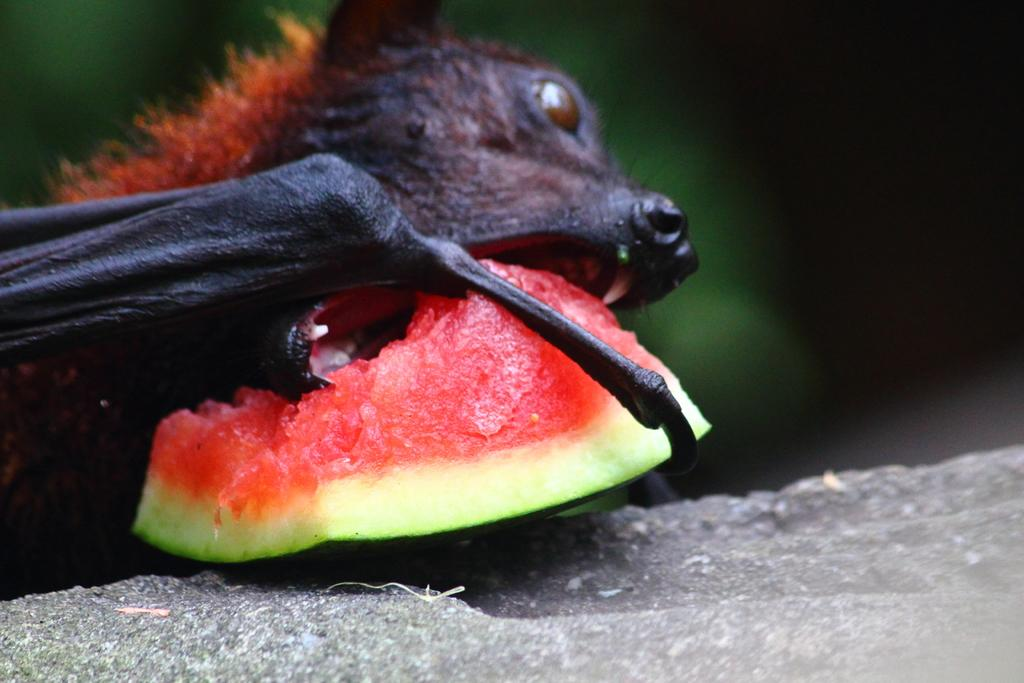What type of animal can be seen in the image? There is a black color animal in the image. What fruit is present in the image? There is a watermelon in the image. Can you describe the background of the image? The background of the image is blurred. What type of shade is covering the animal in the image? There is no shade covering the animal in the image; it is not mentioned in the provided facts. 